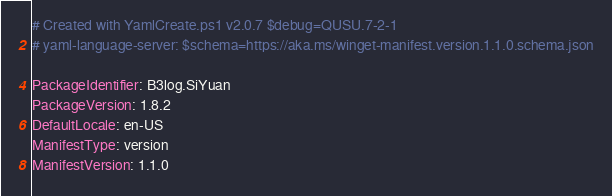Convert code to text. <code><loc_0><loc_0><loc_500><loc_500><_YAML_># Created with YamlCreate.ps1 v2.0.7 $debug=QUSU.7-2-1
# yaml-language-server: $schema=https://aka.ms/winget-manifest.version.1.1.0.schema.json

PackageIdentifier: B3log.SiYuan
PackageVersion: 1.8.2
DefaultLocale: en-US
ManifestType: version
ManifestVersion: 1.1.0
</code> 